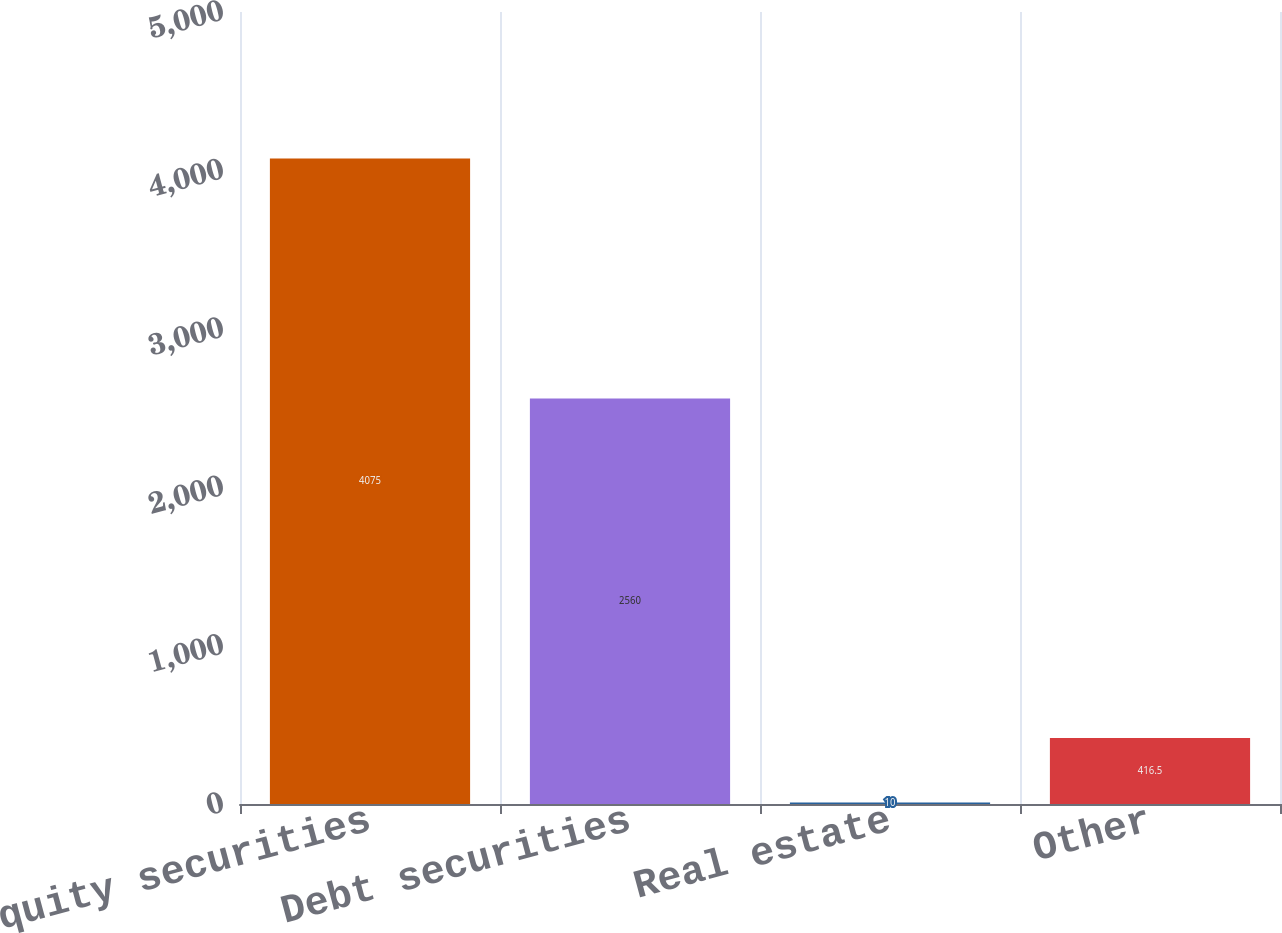Convert chart. <chart><loc_0><loc_0><loc_500><loc_500><bar_chart><fcel>Equity securities<fcel>Debt securities<fcel>Real estate<fcel>Other<nl><fcel>4075<fcel>2560<fcel>10<fcel>416.5<nl></chart> 